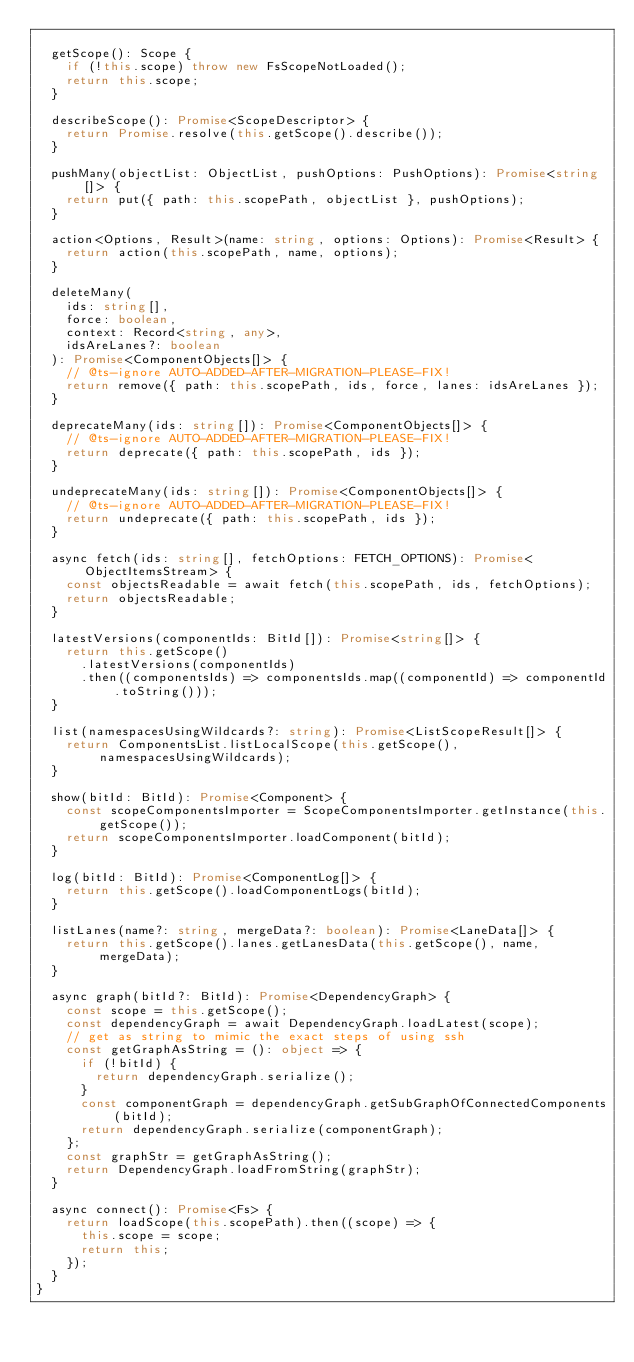<code> <loc_0><loc_0><loc_500><loc_500><_TypeScript_>
  getScope(): Scope {
    if (!this.scope) throw new FsScopeNotLoaded();
    return this.scope;
  }

  describeScope(): Promise<ScopeDescriptor> {
    return Promise.resolve(this.getScope().describe());
  }

  pushMany(objectList: ObjectList, pushOptions: PushOptions): Promise<string[]> {
    return put({ path: this.scopePath, objectList }, pushOptions);
  }

  action<Options, Result>(name: string, options: Options): Promise<Result> {
    return action(this.scopePath, name, options);
  }

  deleteMany(
    ids: string[],
    force: boolean,
    context: Record<string, any>,
    idsAreLanes?: boolean
  ): Promise<ComponentObjects[]> {
    // @ts-ignore AUTO-ADDED-AFTER-MIGRATION-PLEASE-FIX!
    return remove({ path: this.scopePath, ids, force, lanes: idsAreLanes });
  }

  deprecateMany(ids: string[]): Promise<ComponentObjects[]> {
    // @ts-ignore AUTO-ADDED-AFTER-MIGRATION-PLEASE-FIX!
    return deprecate({ path: this.scopePath, ids });
  }

  undeprecateMany(ids: string[]): Promise<ComponentObjects[]> {
    // @ts-ignore AUTO-ADDED-AFTER-MIGRATION-PLEASE-FIX!
    return undeprecate({ path: this.scopePath, ids });
  }

  async fetch(ids: string[], fetchOptions: FETCH_OPTIONS): Promise<ObjectItemsStream> {
    const objectsReadable = await fetch(this.scopePath, ids, fetchOptions);
    return objectsReadable;
  }

  latestVersions(componentIds: BitId[]): Promise<string[]> {
    return this.getScope()
      .latestVersions(componentIds)
      .then((componentsIds) => componentsIds.map((componentId) => componentId.toString()));
  }

  list(namespacesUsingWildcards?: string): Promise<ListScopeResult[]> {
    return ComponentsList.listLocalScope(this.getScope(), namespacesUsingWildcards);
  }

  show(bitId: BitId): Promise<Component> {
    const scopeComponentsImporter = ScopeComponentsImporter.getInstance(this.getScope());
    return scopeComponentsImporter.loadComponent(bitId);
  }

  log(bitId: BitId): Promise<ComponentLog[]> {
    return this.getScope().loadComponentLogs(bitId);
  }

  listLanes(name?: string, mergeData?: boolean): Promise<LaneData[]> {
    return this.getScope().lanes.getLanesData(this.getScope(), name, mergeData);
  }

  async graph(bitId?: BitId): Promise<DependencyGraph> {
    const scope = this.getScope();
    const dependencyGraph = await DependencyGraph.loadLatest(scope);
    // get as string to mimic the exact steps of using ssh
    const getGraphAsString = (): object => {
      if (!bitId) {
        return dependencyGraph.serialize();
      }
      const componentGraph = dependencyGraph.getSubGraphOfConnectedComponents(bitId);
      return dependencyGraph.serialize(componentGraph);
    };
    const graphStr = getGraphAsString();
    return DependencyGraph.loadFromString(graphStr);
  }

  async connect(): Promise<Fs> {
    return loadScope(this.scopePath).then((scope) => {
      this.scope = scope;
      return this;
    });
  }
}
</code> 